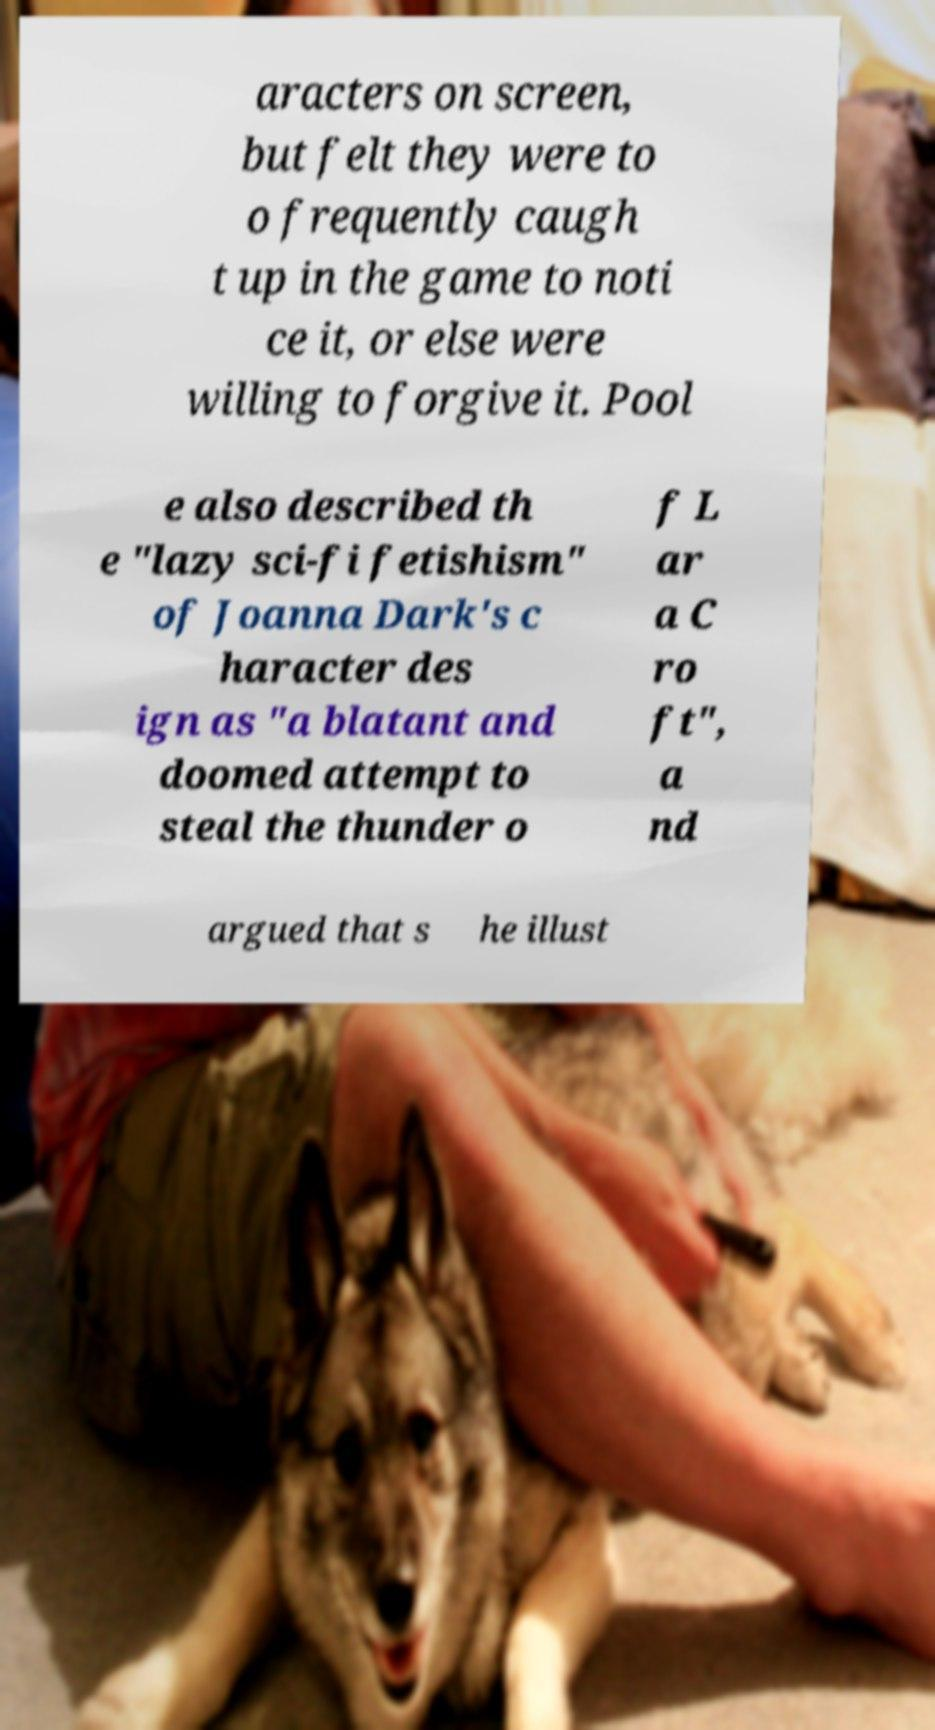Could you extract and type out the text from this image? aracters on screen, but felt they were to o frequently caugh t up in the game to noti ce it, or else were willing to forgive it. Pool e also described th e "lazy sci-fi fetishism" of Joanna Dark's c haracter des ign as "a blatant and doomed attempt to steal the thunder o f L ar a C ro ft", a nd argued that s he illust 